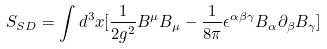Convert formula to latex. <formula><loc_0><loc_0><loc_500><loc_500>S _ { S D } = \int d ^ { 3 } x [ \frac { 1 } { 2 g ^ { 2 } } B ^ { \mu } B _ { \mu } - \frac { 1 } { 8 \pi } \epsilon ^ { \alpha \beta \gamma } B _ { \alpha } \partial _ { \beta } B _ { \gamma } ]</formula> 